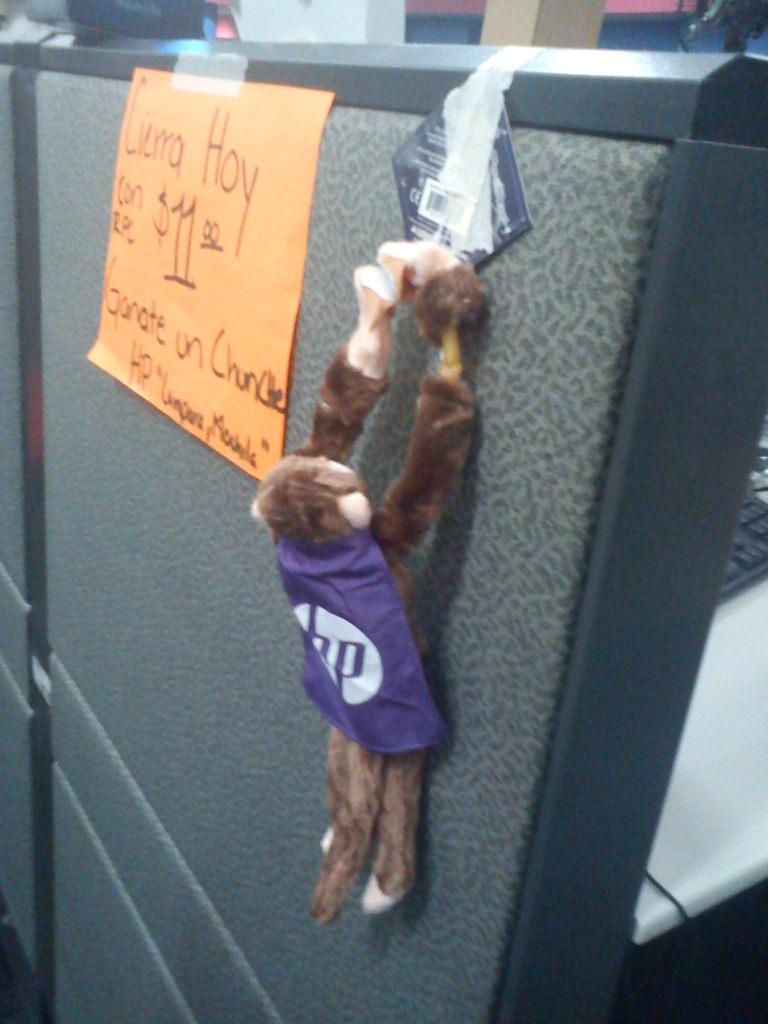What is the main object in the image? There is a black board in the image. What is written or displayed on the black board? There is a chart on the black board. Is there any additional decoration or attachment on the black board? Yes, there is a show piece attached to the black board. What can be seen on the right side of the image? There is a desk in the right side of the image. What object is placed on the desk? There is a keyboard on the desk. What type of ink is being used to write on the black board? There is no ink being used to write on the black board, as it is a chart, not written text. 